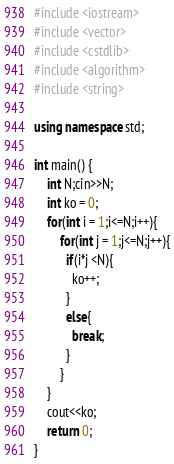Convert code to text. <code><loc_0><loc_0><loc_500><loc_500><_C++_>#include <iostream>
#include <vector>
#include <cstdlib>  
#include <algorithm>
#include <string>

using namespace std;
 
int main() {
    int N;cin>>N;
    int ko = 0;
    for(int i = 1;i<=N;i++){
    	for(int j = 1;j<=N;j++){
          if(i*j <N){
          	ko++;
          }
          else{
          	break;
          }
        }
    }
    cout<<ko;
    return 0;
}</code> 